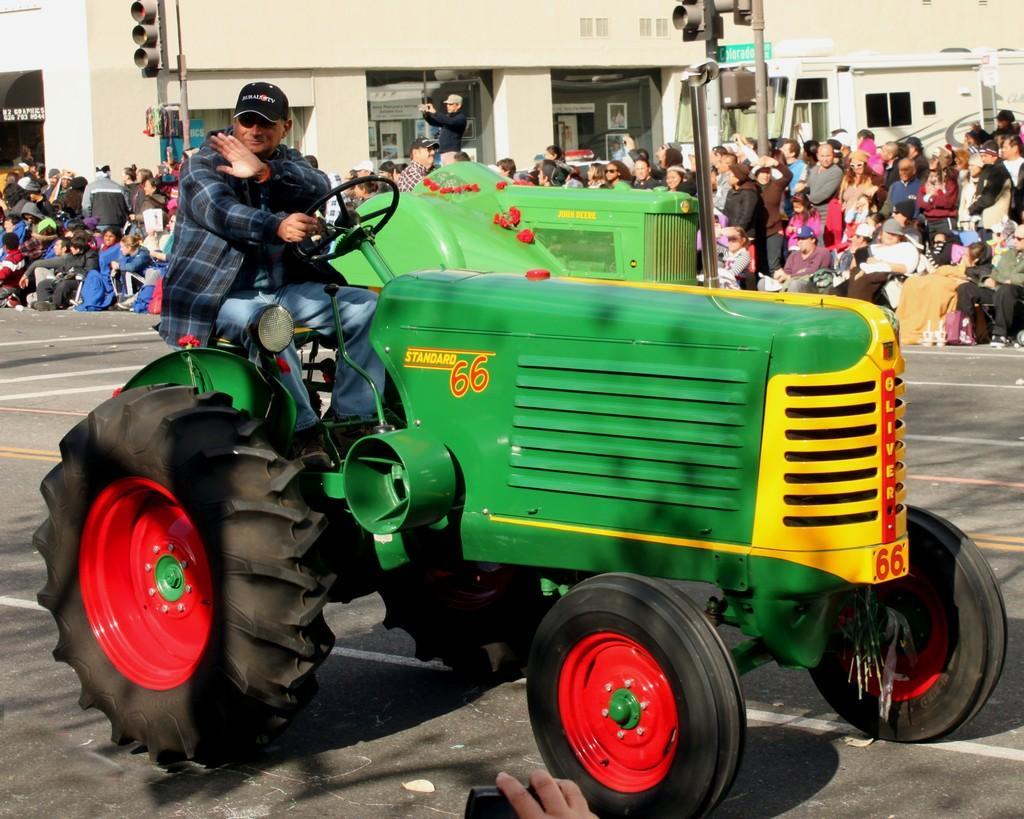Describe this image in one or two sentences. On the left side of the image we can see the crowd and a traffic signal. In the middle of the image we can see a vehicle on which a person is sitting. On the right side of the image we can see the crowd. 